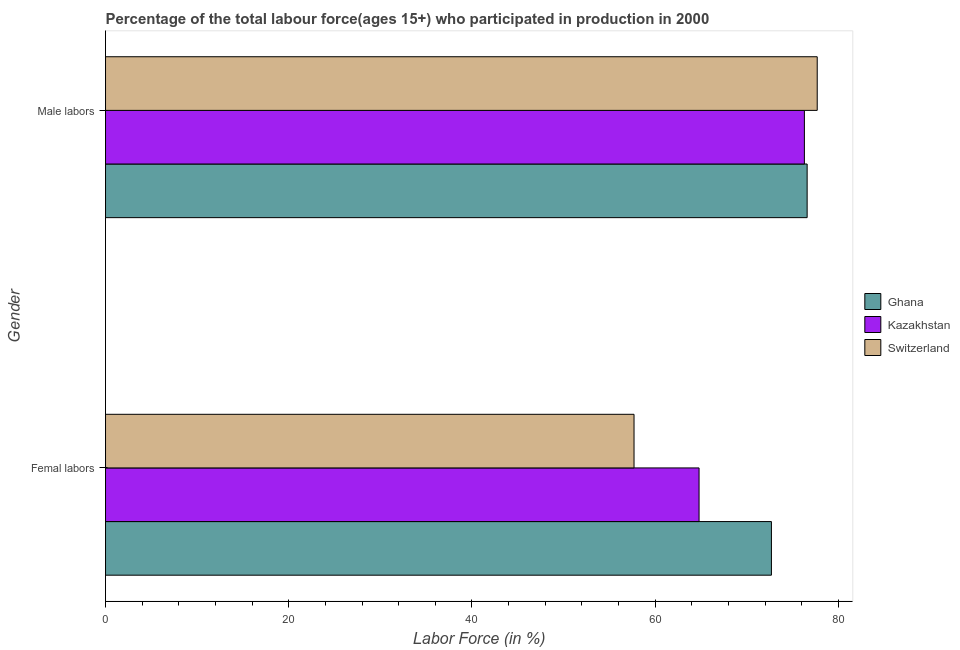How many groups of bars are there?
Provide a short and direct response. 2. Are the number of bars on each tick of the Y-axis equal?
Your response must be concise. Yes. How many bars are there on the 1st tick from the bottom?
Provide a short and direct response. 3. What is the label of the 2nd group of bars from the top?
Offer a terse response. Femal labors. What is the percentage of male labour force in Switzerland?
Make the answer very short. 77.7. Across all countries, what is the maximum percentage of male labour force?
Your answer should be compact. 77.7. Across all countries, what is the minimum percentage of female labor force?
Your answer should be compact. 57.7. In which country was the percentage of male labour force maximum?
Provide a succinct answer. Switzerland. In which country was the percentage of female labor force minimum?
Offer a very short reply. Switzerland. What is the total percentage of male labour force in the graph?
Offer a very short reply. 230.6. What is the difference between the percentage of male labour force in Kazakhstan and that in Ghana?
Your answer should be very brief. -0.3. What is the difference between the percentage of female labor force in Kazakhstan and the percentage of male labour force in Switzerland?
Make the answer very short. -12.9. What is the average percentage of male labour force per country?
Make the answer very short. 76.87. What is the difference between the percentage of male labour force and percentage of female labor force in Ghana?
Your answer should be compact. 3.9. In how many countries, is the percentage of female labor force greater than 60 %?
Make the answer very short. 2. What is the ratio of the percentage of male labour force in Ghana to that in Kazakhstan?
Make the answer very short. 1. Is the percentage of female labor force in Kazakhstan less than that in Ghana?
Provide a succinct answer. Yes. What does the 1st bar from the top in Femal labors represents?
Provide a short and direct response. Switzerland. What does the 1st bar from the bottom in Male labors represents?
Provide a succinct answer. Ghana. How many countries are there in the graph?
Ensure brevity in your answer.  3. What is the difference between two consecutive major ticks on the X-axis?
Your response must be concise. 20. Does the graph contain any zero values?
Your response must be concise. No. Does the graph contain grids?
Your answer should be compact. No. What is the title of the graph?
Make the answer very short. Percentage of the total labour force(ages 15+) who participated in production in 2000. Does "Uruguay" appear as one of the legend labels in the graph?
Your answer should be very brief. No. What is the label or title of the X-axis?
Provide a succinct answer. Labor Force (in %). What is the label or title of the Y-axis?
Give a very brief answer. Gender. What is the Labor Force (in %) in Ghana in Femal labors?
Your answer should be compact. 72.7. What is the Labor Force (in %) of Kazakhstan in Femal labors?
Provide a short and direct response. 64.8. What is the Labor Force (in %) in Switzerland in Femal labors?
Your answer should be very brief. 57.7. What is the Labor Force (in %) of Ghana in Male labors?
Your answer should be very brief. 76.6. What is the Labor Force (in %) in Kazakhstan in Male labors?
Offer a very short reply. 76.3. What is the Labor Force (in %) of Switzerland in Male labors?
Your answer should be compact. 77.7. Across all Gender, what is the maximum Labor Force (in %) in Ghana?
Your answer should be very brief. 76.6. Across all Gender, what is the maximum Labor Force (in %) of Kazakhstan?
Offer a very short reply. 76.3. Across all Gender, what is the maximum Labor Force (in %) in Switzerland?
Provide a succinct answer. 77.7. Across all Gender, what is the minimum Labor Force (in %) of Ghana?
Your response must be concise. 72.7. Across all Gender, what is the minimum Labor Force (in %) of Kazakhstan?
Keep it short and to the point. 64.8. Across all Gender, what is the minimum Labor Force (in %) in Switzerland?
Your answer should be very brief. 57.7. What is the total Labor Force (in %) in Ghana in the graph?
Provide a succinct answer. 149.3. What is the total Labor Force (in %) in Kazakhstan in the graph?
Keep it short and to the point. 141.1. What is the total Labor Force (in %) of Switzerland in the graph?
Ensure brevity in your answer.  135.4. What is the difference between the Labor Force (in %) in Kazakhstan in Femal labors and that in Male labors?
Your answer should be compact. -11.5. What is the difference between the Labor Force (in %) in Switzerland in Femal labors and that in Male labors?
Your answer should be very brief. -20. What is the difference between the Labor Force (in %) of Kazakhstan in Femal labors and the Labor Force (in %) of Switzerland in Male labors?
Make the answer very short. -12.9. What is the average Labor Force (in %) in Ghana per Gender?
Offer a very short reply. 74.65. What is the average Labor Force (in %) in Kazakhstan per Gender?
Your answer should be very brief. 70.55. What is the average Labor Force (in %) in Switzerland per Gender?
Provide a succinct answer. 67.7. What is the difference between the Labor Force (in %) in Ghana and Labor Force (in %) in Kazakhstan in Male labors?
Your answer should be compact. 0.3. What is the difference between the Labor Force (in %) of Ghana and Labor Force (in %) of Switzerland in Male labors?
Give a very brief answer. -1.1. What is the difference between the Labor Force (in %) of Kazakhstan and Labor Force (in %) of Switzerland in Male labors?
Offer a terse response. -1.4. What is the ratio of the Labor Force (in %) in Ghana in Femal labors to that in Male labors?
Your response must be concise. 0.95. What is the ratio of the Labor Force (in %) in Kazakhstan in Femal labors to that in Male labors?
Your answer should be compact. 0.85. What is the ratio of the Labor Force (in %) in Switzerland in Femal labors to that in Male labors?
Provide a short and direct response. 0.74. What is the difference between the highest and the second highest Labor Force (in %) in Kazakhstan?
Make the answer very short. 11.5. What is the difference between the highest and the lowest Labor Force (in %) of Ghana?
Provide a succinct answer. 3.9. What is the difference between the highest and the lowest Labor Force (in %) of Kazakhstan?
Provide a short and direct response. 11.5. 